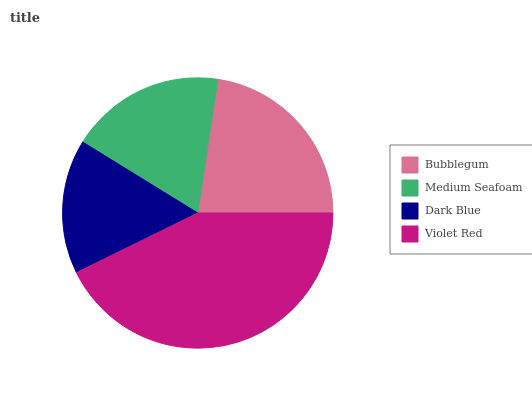Is Dark Blue the minimum?
Answer yes or no. Yes. Is Violet Red the maximum?
Answer yes or no. Yes. Is Medium Seafoam the minimum?
Answer yes or no. No. Is Medium Seafoam the maximum?
Answer yes or no. No. Is Bubblegum greater than Medium Seafoam?
Answer yes or no. Yes. Is Medium Seafoam less than Bubblegum?
Answer yes or no. Yes. Is Medium Seafoam greater than Bubblegum?
Answer yes or no. No. Is Bubblegum less than Medium Seafoam?
Answer yes or no. No. Is Bubblegum the high median?
Answer yes or no. Yes. Is Medium Seafoam the low median?
Answer yes or no. Yes. Is Dark Blue the high median?
Answer yes or no. No. Is Bubblegum the low median?
Answer yes or no. No. 